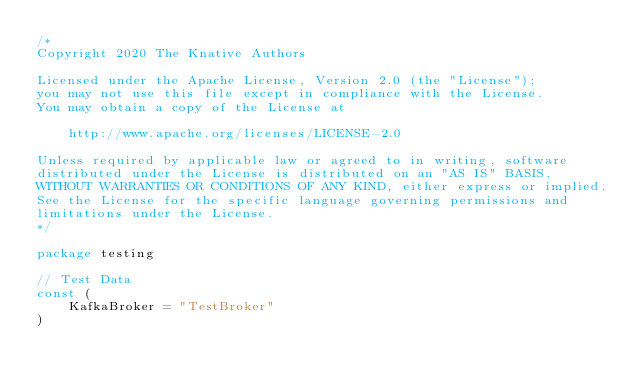<code> <loc_0><loc_0><loc_500><loc_500><_Go_>/*
Copyright 2020 The Knative Authors

Licensed under the Apache License, Version 2.0 (the "License");
you may not use this file except in compliance with the License.
You may obtain a copy of the License at

    http://www.apache.org/licenses/LICENSE-2.0

Unless required by applicable law or agreed to in writing, software
distributed under the License is distributed on an "AS IS" BASIS,
WITHOUT WARRANTIES OR CONDITIONS OF ANY KIND, either express or implied.
See the License for the specific language governing permissions and
limitations under the License.
*/

package testing

// Test Data
const (
	KafkaBroker = "TestBroker"
)
</code> 